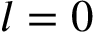<formula> <loc_0><loc_0><loc_500><loc_500>l = 0</formula> 